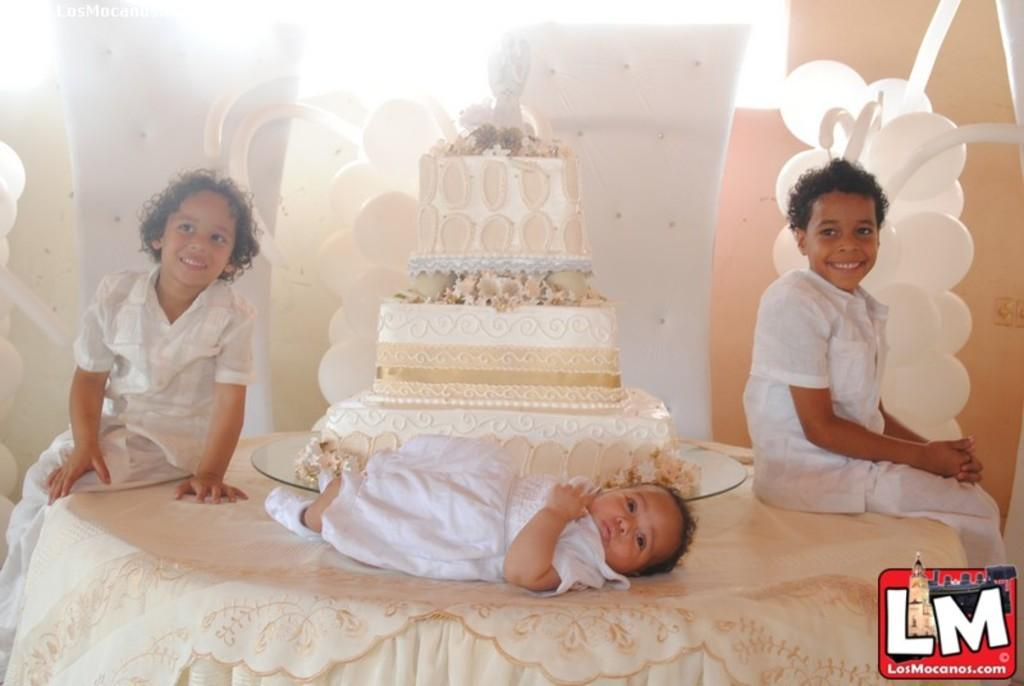How many children are present in the image? There are two children sitting in the image. What is the facial expression of the children? The children are smiling. What is the age of the child lying in the image? The fact does not specify the age of the baby, but it is lying in the image. What is on the table in the image? There is a cake on a table in the image. What color are the balloons in the image? The balloons in the image are white. What is the background of the image? There is a wall in the image. What type of advice can be seen written on the wall in the image? There is no advice written on the wall in the image; it is just a wall. What is the mass of the cake on the table in the image? The mass of the cake cannot be determined from the image alone, as it is a visual representation and not a physical object. 